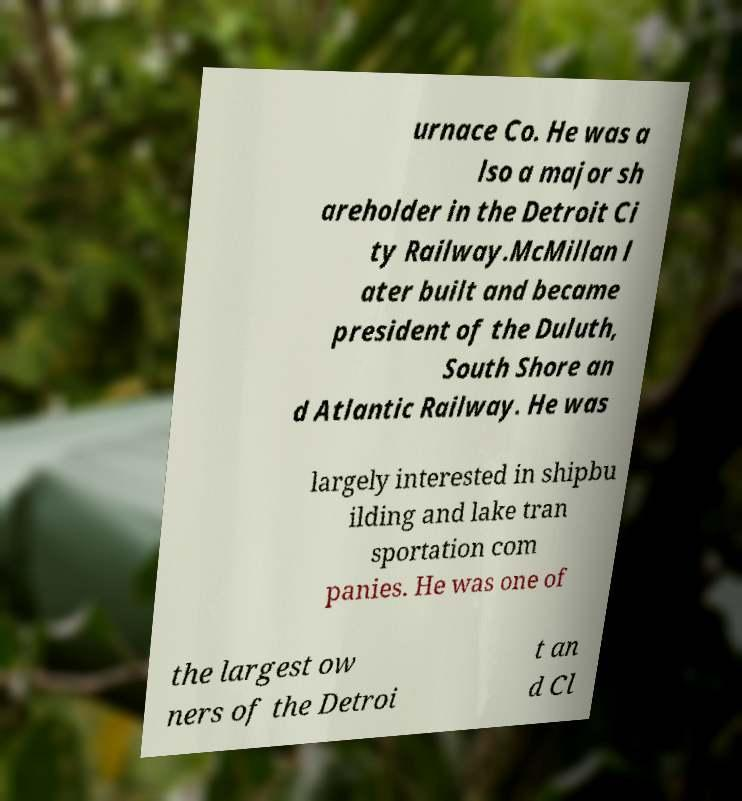There's text embedded in this image that I need extracted. Can you transcribe it verbatim? urnace Co. He was a lso a major sh areholder in the Detroit Ci ty Railway.McMillan l ater built and became president of the Duluth, South Shore an d Atlantic Railway. He was largely interested in shipbu ilding and lake tran sportation com panies. He was one of the largest ow ners of the Detroi t an d Cl 